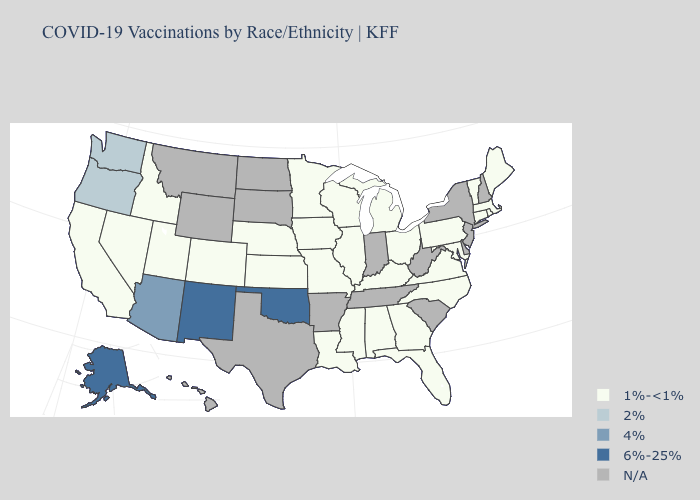Among the states that border Oregon , does Washington have the lowest value?
Concise answer only. No. Which states hav the highest value in the Northeast?
Keep it brief. Connecticut, Maine, Massachusetts, Pennsylvania, Rhode Island, Vermont. Does the map have missing data?
Concise answer only. Yes. What is the lowest value in the USA?
Give a very brief answer. 1%-<1%. What is the value of Wisconsin?
Quick response, please. 1%-<1%. Name the states that have a value in the range N/A?
Be succinct. Arkansas, Delaware, Hawaii, Indiana, Montana, New Hampshire, New Jersey, New York, North Dakota, South Carolina, South Dakota, Tennessee, Texas, West Virginia, Wyoming. Name the states that have a value in the range N/A?
Keep it brief. Arkansas, Delaware, Hawaii, Indiana, Montana, New Hampshire, New Jersey, New York, North Dakota, South Carolina, South Dakota, Tennessee, Texas, West Virginia, Wyoming. What is the lowest value in states that border New York?
Answer briefly. 1%-<1%. What is the lowest value in the USA?
Answer briefly. 1%-<1%. Name the states that have a value in the range 6%-25%?
Be succinct. Alaska, New Mexico, Oklahoma. What is the value of California?
Keep it brief. 1%-<1%. Does the first symbol in the legend represent the smallest category?
Give a very brief answer. Yes. What is the highest value in the USA?
Short answer required. 6%-25%. 